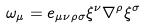<formula> <loc_0><loc_0><loc_500><loc_500>\omega _ { \mu } = e _ { \mu \nu \rho \sigma } \xi ^ { \nu } \nabla ^ { \rho } \xi ^ { \sigma }</formula> 